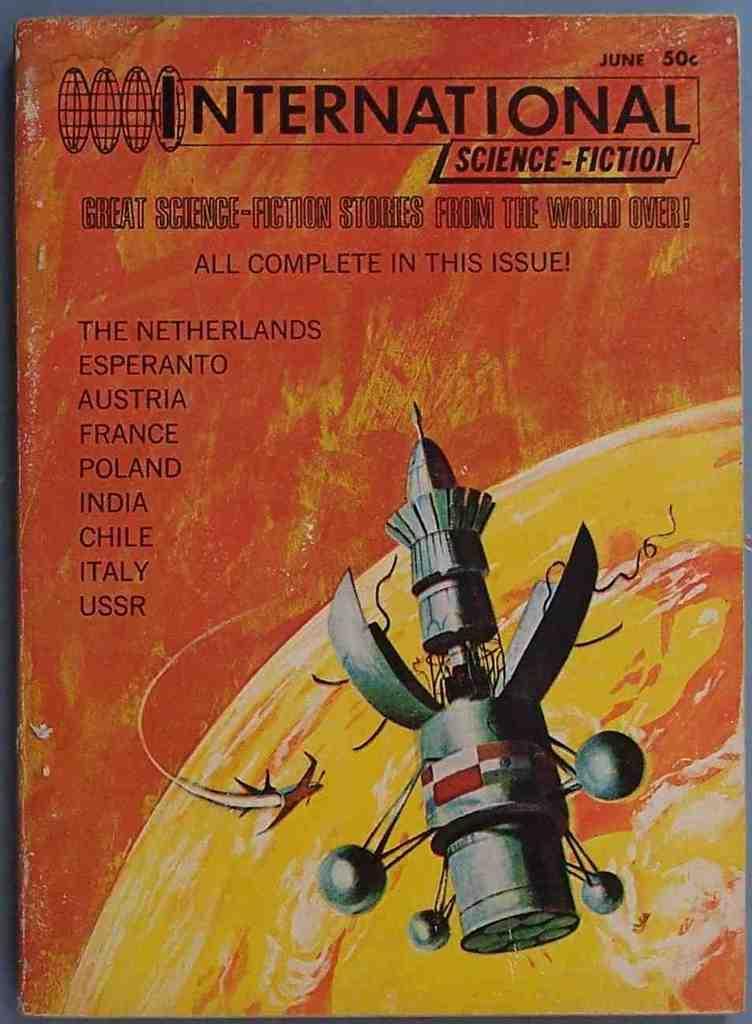Please provide a concise description of this image. Picture of a book. Above this book we can see an animated picture of a rocket. Something written on this book.   